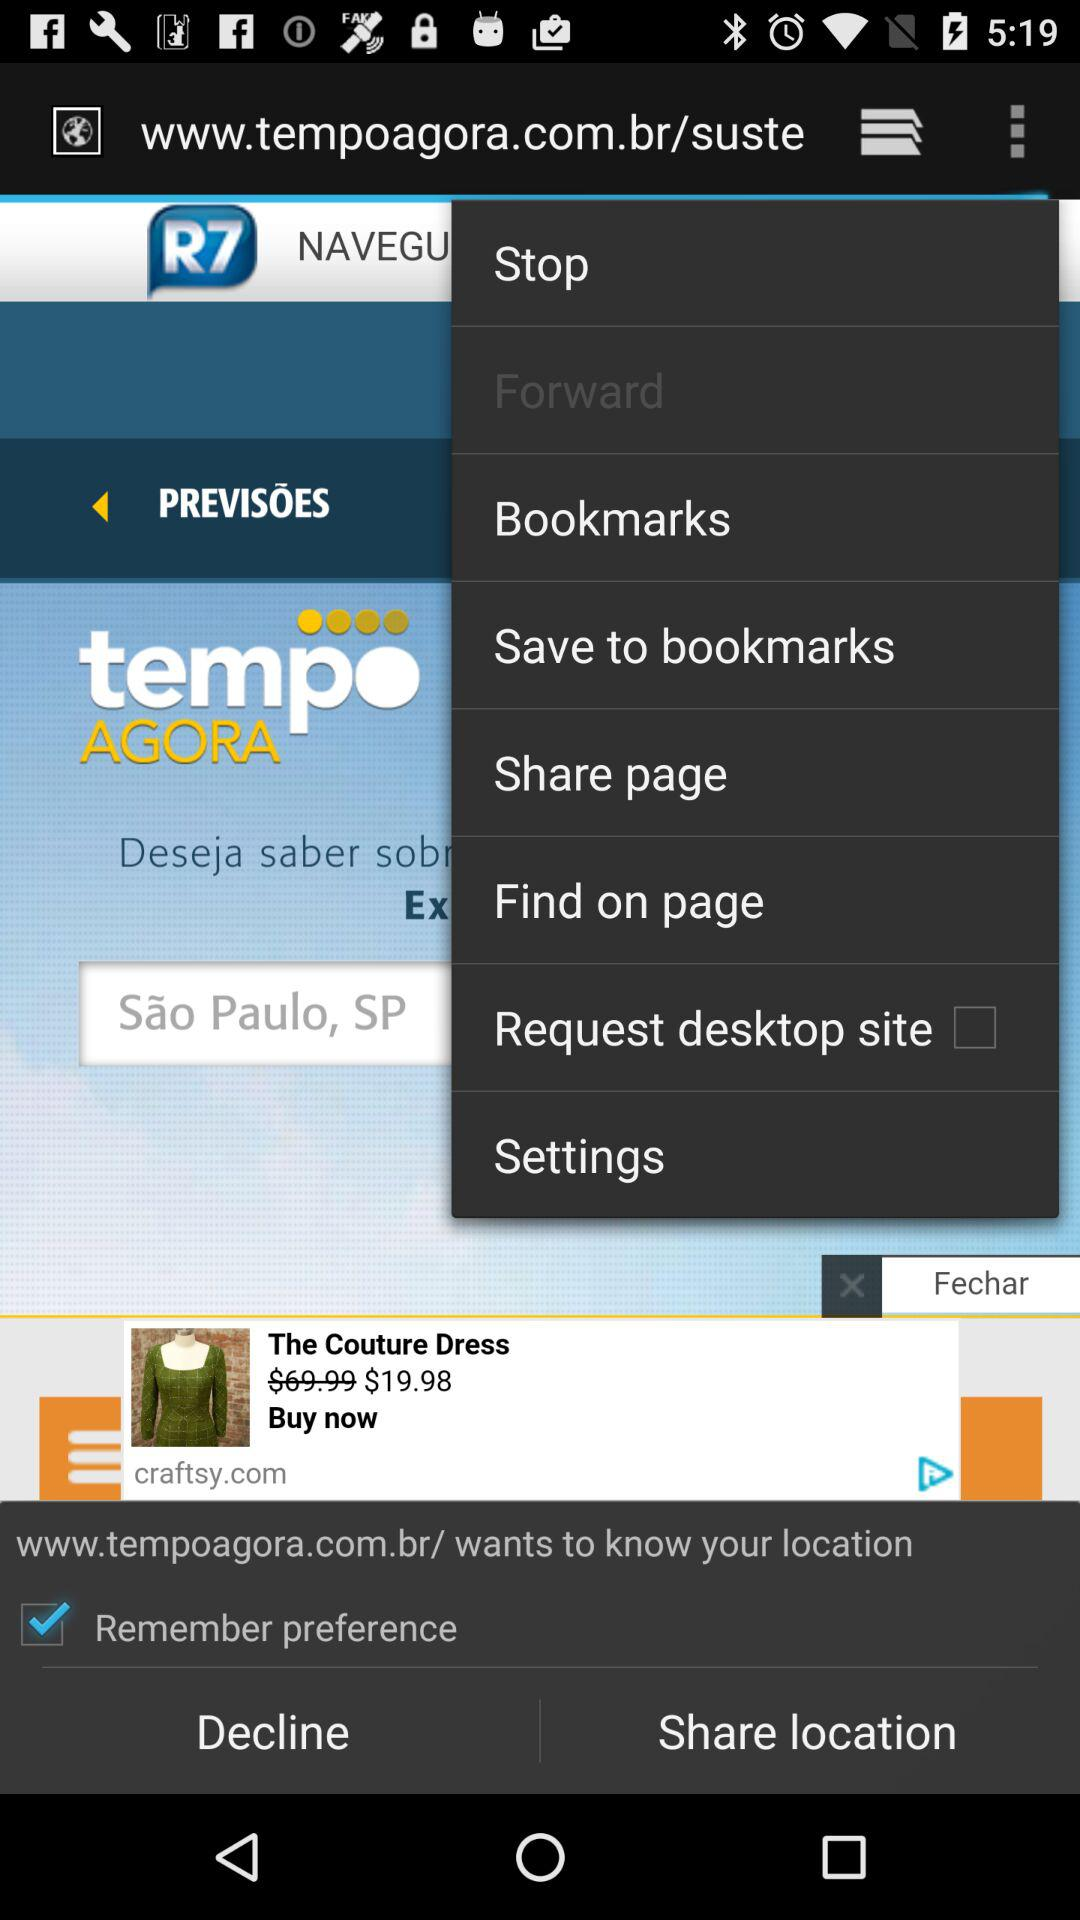What website is asking for location permission? The website that is asking for location permission is www.tempoagora.com.br/. 